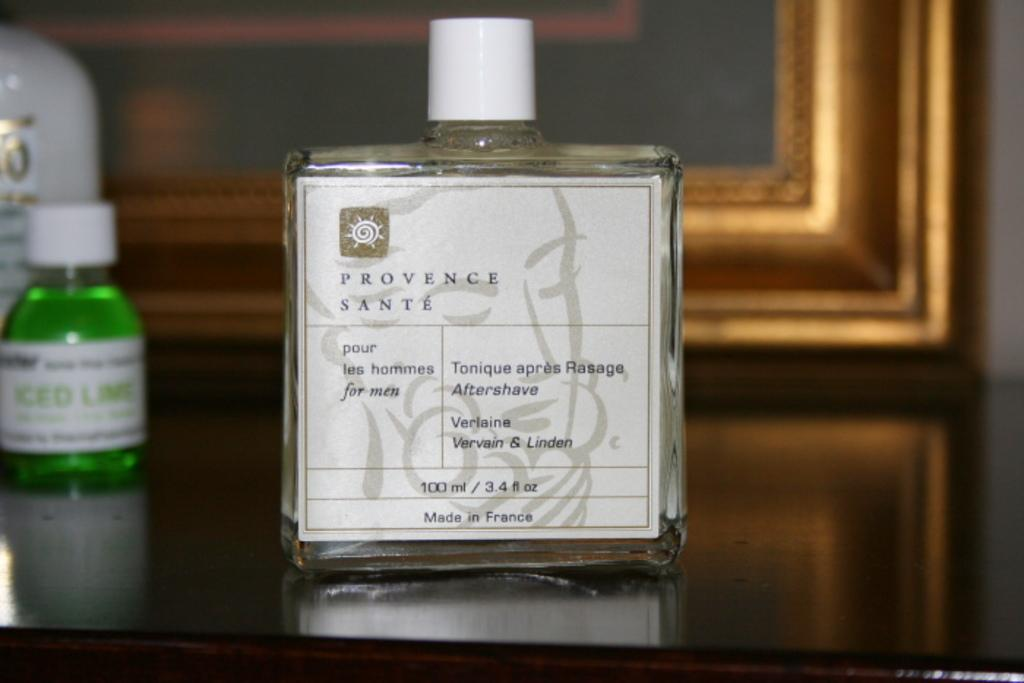Provide a one-sentence caption for the provided image. A bottle with a white label that is 100 ml of aftershave. 